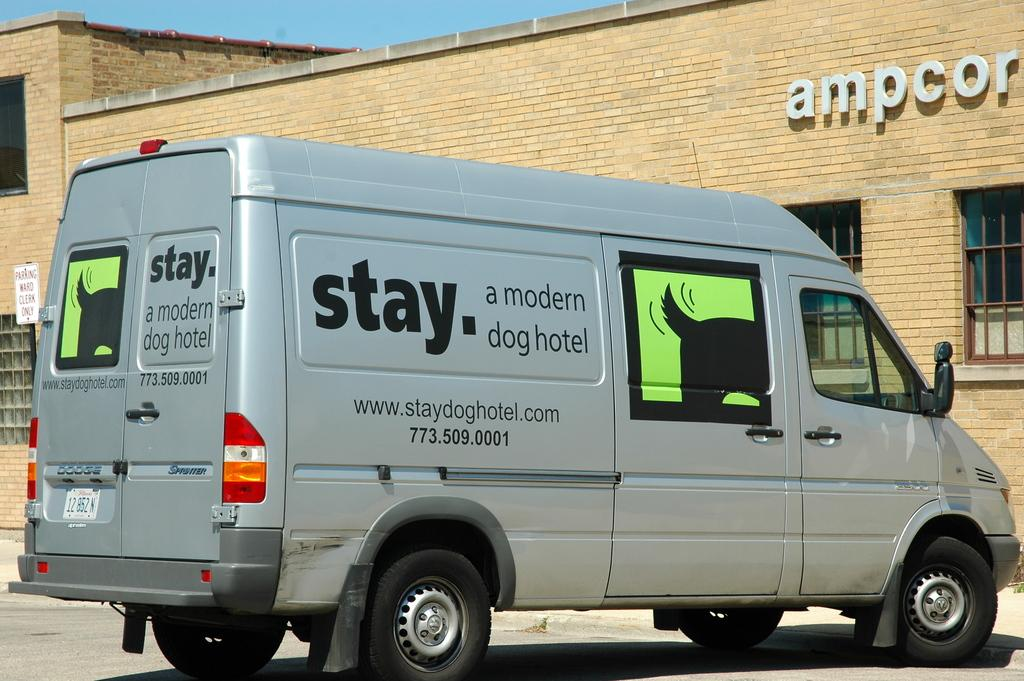Provide a one-sentence caption for the provided image. A van decorated with a picture of a dogs wagging tail belongs to the dog hotel company. 